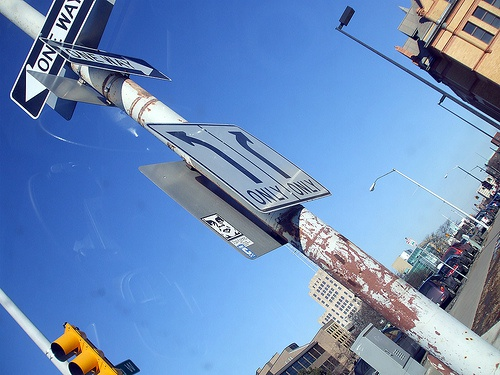Describe the objects in this image and their specific colors. I can see traffic light in lightgray, orange, black, navy, and red tones, car in lightgray, black, navy, gray, and darkblue tones, car in lightgray, navy, black, gray, and darkblue tones, car in lightgray, black, navy, gray, and darkblue tones, and car in lightgray, gray, black, navy, and purple tones in this image. 